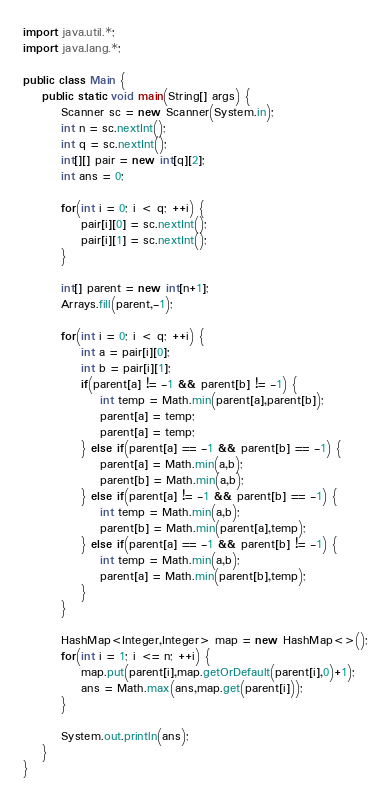Convert code to text. <code><loc_0><loc_0><loc_500><loc_500><_Java_>import java.util.*;
import java.lang.*;

public class Main {
	public static void main(String[] args) {
		Scanner sc = new Scanner(System.in);
		int n = sc.nextInt();
		int q = sc.nextInt();
		int[][] pair = new int[q][2];
		int ans = 0;

		for(int i = 0; i < q; ++i) {
			pair[i][0] = sc.nextInt();
			pair[i][1] = sc.nextInt();
		}

		int[] parent = new int[n+1];
		Arrays.fill(parent,-1);

		for(int i = 0; i < q; ++i) {
			int a = pair[i][0];
			int b = pair[i][1];
			if(parent[a] != -1 && parent[b] != -1) {
				int temp = Math.min(parent[a],parent[b]);
				parent[a] = temp;
				parent[a] = temp;
			} else if(parent[a] == -1 && parent[b] == -1) {
				parent[a] = Math.min(a,b);
				parent[b] = Math.min(a,b);
			} else if(parent[a] != -1 && parent[b] == -1) {
				int temp = Math.min(a,b);
				parent[b] = Math.min(parent[a],temp);
			} else if(parent[a] == -1 && parent[b] != -1) {
				int temp = Math.min(a,b);
				parent[a] = Math.min(parent[b],temp);
			}
		}

		HashMap<Integer,Integer> map = new HashMap<>();
		for(int i = 1; i <= n; ++i) {
			map.put(parent[i],map.getOrDefault(parent[i],0)+1);
			ans = Math.max(ans,map.get(parent[i]));
		}

		System.out.println(ans);
	}
}</code> 